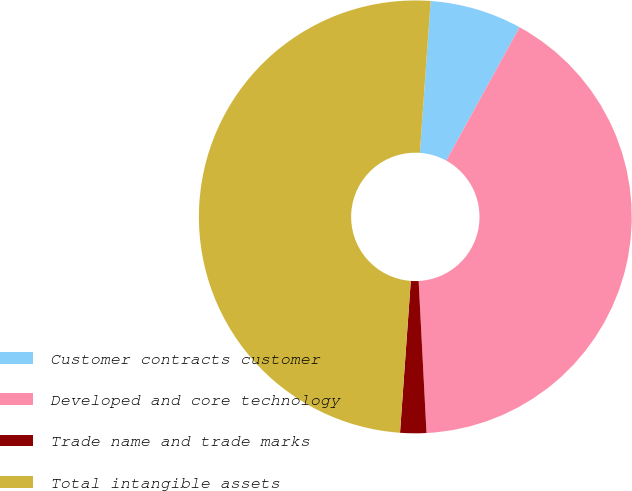Convert chart. <chart><loc_0><loc_0><loc_500><loc_500><pie_chart><fcel>Customer contracts customer<fcel>Developed and core technology<fcel>Trade name and trade marks<fcel>Total intangible assets<nl><fcel>6.87%<fcel>41.18%<fcel>1.95%<fcel>50.0%<nl></chart> 